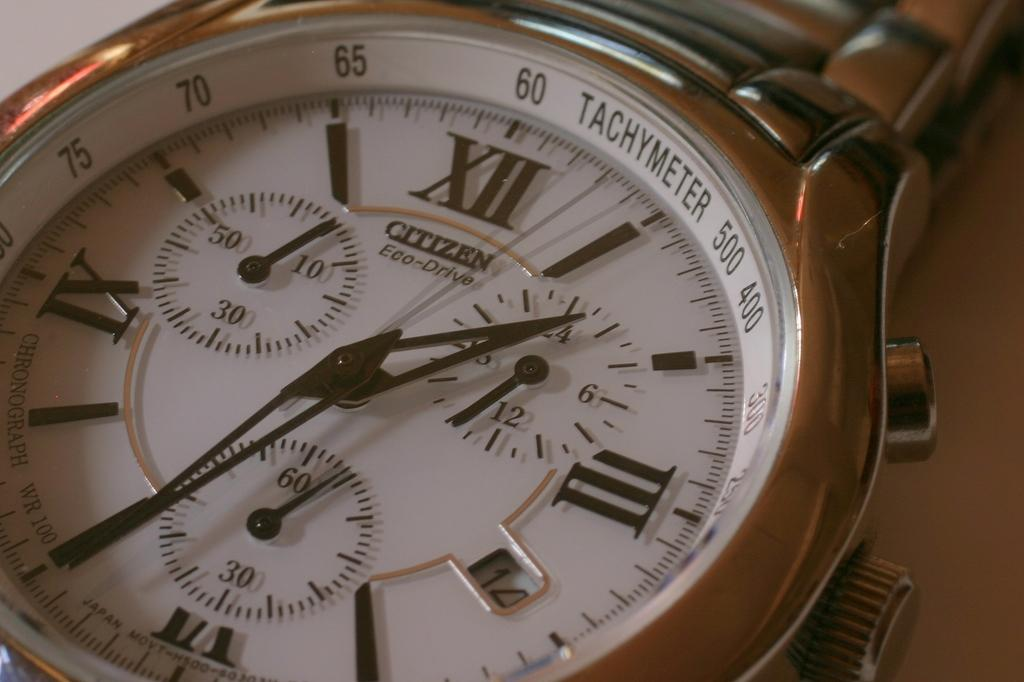<image>
Render a clear and concise summary of the photo. Face of a watch that says the word CITIZEN on it. 